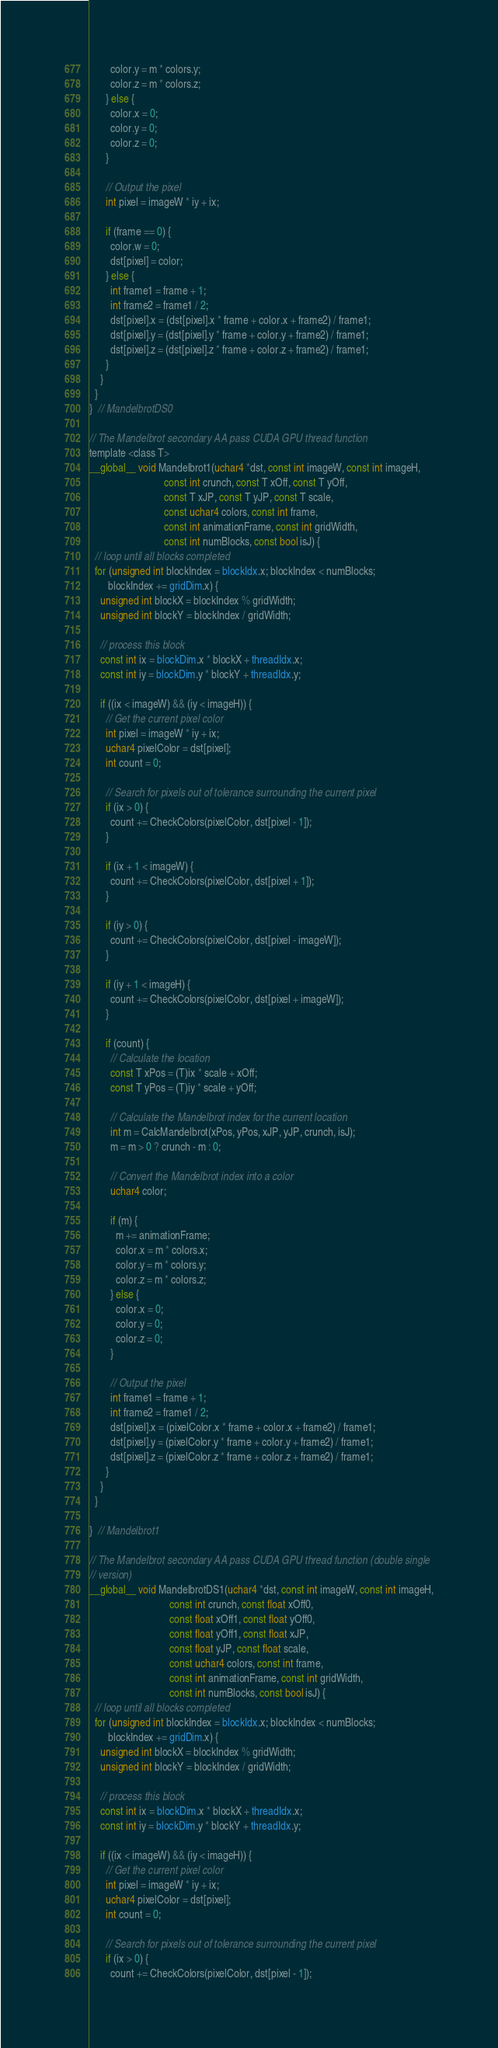<code> <loc_0><loc_0><loc_500><loc_500><_Cuda_>        color.y = m * colors.y;
        color.z = m * colors.z;
      } else {
        color.x = 0;
        color.y = 0;
        color.z = 0;
      }

      // Output the pixel
      int pixel = imageW * iy + ix;

      if (frame == 0) {
        color.w = 0;
        dst[pixel] = color;
      } else {
        int frame1 = frame + 1;
        int frame2 = frame1 / 2;
        dst[pixel].x = (dst[pixel].x * frame + color.x + frame2) / frame1;
        dst[pixel].y = (dst[pixel].y * frame + color.y + frame2) / frame1;
        dst[pixel].z = (dst[pixel].z * frame + color.z + frame2) / frame1;
      }
    }
  }
}  // MandelbrotDS0

// The Mandelbrot secondary AA pass CUDA GPU thread function
template <class T>
__global__ void Mandelbrot1(uchar4 *dst, const int imageW, const int imageH,
                            const int crunch, const T xOff, const T yOff,
                            const T xJP, const T yJP, const T scale,
                            const uchar4 colors, const int frame,
                            const int animationFrame, const int gridWidth,
                            const int numBlocks, const bool isJ) {
  // loop until all blocks completed
  for (unsigned int blockIndex = blockIdx.x; blockIndex < numBlocks;
       blockIndex += gridDim.x) {
    unsigned int blockX = blockIndex % gridWidth;
    unsigned int blockY = blockIndex / gridWidth;

    // process this block
    const int ix = blockDim.x * blockX + threadIdx.x;
    const int iy = blockDim.y * blockY + threadIdx.y;

    if ((ix < imageW) && (iy < imageH)) {
      // Get the current pixel color
      int pixel = imageW * iy + ix;
      uchar4 pixelColor = dst[pixel];
      int count = 0;

      // Search for pixels out of tolerance surrounding the current pixel
      if (ix > 0) {
        count += CheckColors(pixelColor, dst[pixel - 1]);
      }

      if (ix + 1 < imageW) {
        count += CheckColors(pixelColor, dst[pixel + 1]);
      }

      if (iy > 0) {
        count += CheckColors(pixelColor, dst[pixel - imageW]);
      }

      if (iy + 1 < imageH) {
        count += CheckColors(pixelColor, dst[pixel + imageW]);
      }

      if (count) {
        // Calculate the location
        const T xPos = (T)ix * scale + xOff;
        const T yPos = (T)iy * scale + yOff;

        // Calculate the Mandelbrot index for the current location
        int m = CalcMandelbrot(xPos, yPos, xJP, yJP, crunch, isJ);
        m = m > 0 ? crunch - m : 0;

        // Convert the Mandelbrot index into a color
        uchar4 color;

        if (m) {
          m += animationFrame;
          color.x = m * colors.x;
          color.y = m * colors.y;
          color.z = m * colors.z;
        } else {
          color.x = 0;
          color.y = 0;
          color.z = 0;
        }

        // Output the pixel
        int frame1 = frame + 1;
        int frame2 = frame1 / 2;
        dst[pixel].x = (pixelColor.x * frame + color.x + frame2) / frame1;
        dst[pixel].y = (pixelColor.y * frame + color.y + frame2) / frame1;
        dst[pixel].z = (pixelColor.z * frame + color.z + frame2) / frame1;
      }
    }
  }

}  // Mandelbrot1

// The Mandelbrot secondary AA pass CUDA GPU thread function (double single
// version)
__global__ void MandelbrotDS1(uchar4 *dst, const int imageW, const int imageH,
                              const int crunch, const float xOff0,
                              const float xOff1, const float yOff0,
                              const float yOff1, const float xJP,
                              const float yJP, const float scale,
                              const uchar4 colors, const int frame,
                              const int animationFrame, const int gridWidth,
                              const int numBlocks, const bool isJ) {
  // loop until all blocks completed
  for (unsigned int blockIndex = blockIdx.x; blockIndex < numBlocks;
       blockIndex += gridDim.x) {
    unsigned int blockX = blockIndex % gridWidth;
    unsigned int blockY = blockIndex / gridWidth;

    // process this block
    const int ix = blockDim.x * blockX + threadIdx.x;
    const int iy = blockDim.y * blockY + threadIdx.y;

    if ((ix < imageW) && (iy < imageH)) {
      // Get the current pixel color
      int pixel = imageW * iy + ix;
      uchar4 pixelColor = dst[pixel];
      int count = 0;

      // Search for pixels out of tolerance surrounding the current pixel
      if (ix > 0) {
        count += CheckColors(pixelColor, dst[pixel - 1]);</code> 